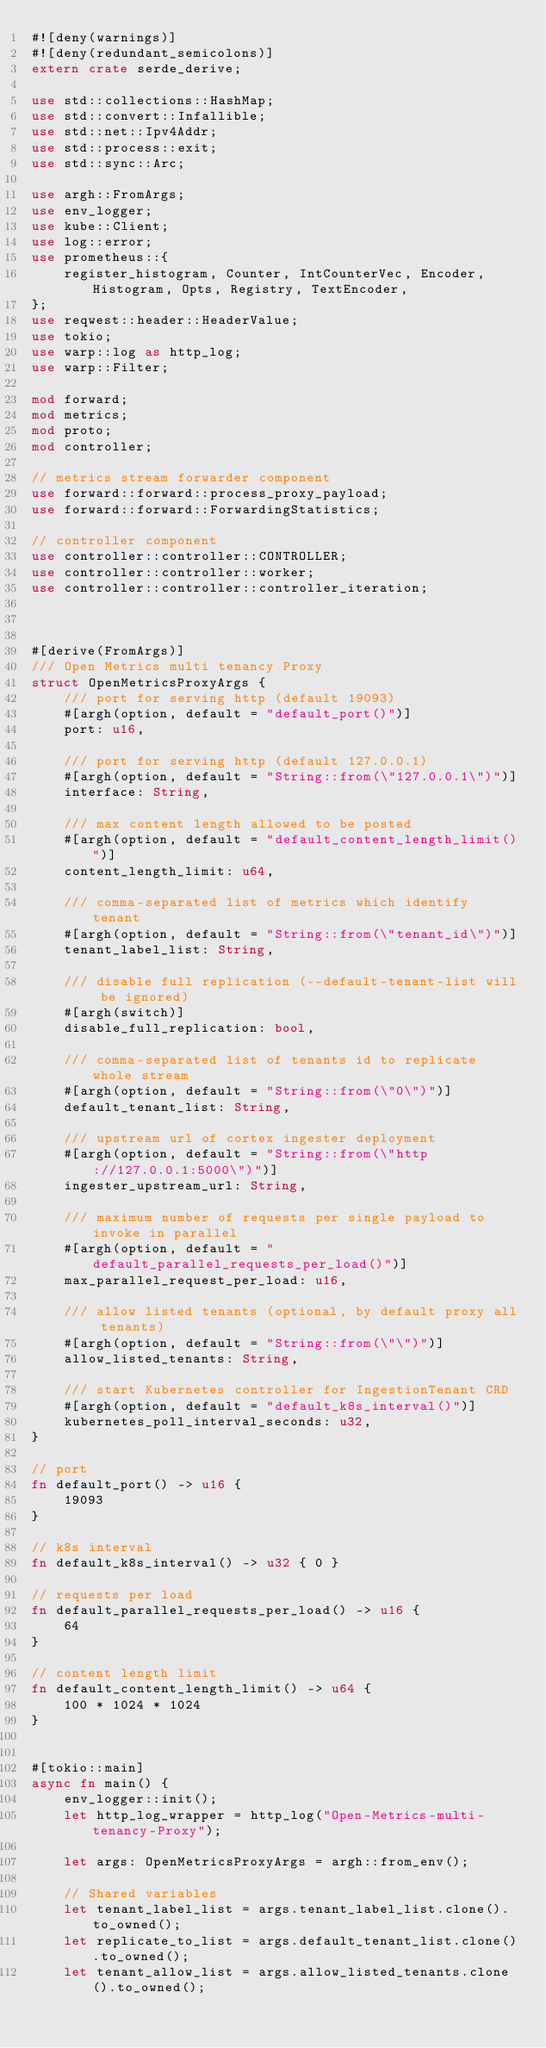<code> <loc_0><loc_0><loc_500><loc_500><_Rust_>#![deny(warnings)]
#![deny(redundant_semicolons)]
extern crate serde_derive;

use std::collections::HashMap;
use std::convert::Infallible;
use std::net::Ipv4Addr;
use std::process::exit;
use std::sync::Arc;

use argh::FromArgs;
use env_logger;
use kube::Client;
use log::error;
use prometheus::{
    register_histogram, Counter, IntCounterVec, Encoder, Histogram, Opts, Registry, TextEncoder,
};
use reqwest::header::HeaderValue;
use tokio;
use warp::log as http_log;
use warp::Filter;

mod forward;
mod metrics;
mod proto;
mod controller;

// metrics stream forwarder component
use forward::forward::process_proxy_payload;
use forward::forward::ForwardingStatistics;

// controller component
use controller::controller::CONTROLLER;
use controller::controller::worker;
use controller::controller::controller_iteration;



#[derive(FromArgs)]
/// Open Metrics multi tenancy Proxy
struct OpenMetricsProxyArgs {
    /// port for serving http (default 19093)
    #[argh(option, default = "default_port()")]
    port: u16,

    /// port for serving http (default 127.0.0.1)
    #[argh(option, default = "String::from(\"127.0.0.1\")")]
    interface: String,

    /// max content length allowed to be posted
    #[argh(option, default = "default_content_length_limit()")]
    content_length_limit: u64,

    /// comma-separated list of metrics which identify tenant
    #[argh(option, default = "String::from(\"tenant_id\")")]
    tenant_label_list: String,

    /// disable full replication (--default-tenant-list will be ignored)
    #[argh(switch)]
    disable_full_replication: bool,

    /// comma-separated list of tenants id to replicate whole stream
    #[argh(option, default = "String::from(\"0\")")]
    default_tenant_list: String,

    /// upstream url of cortex ingester deployment
    #[argh(option, default = "String::from(\"http://127.0.0.1:5000\")")]
    ingester_upstream_url: String,

    /// maximum number of requests per single payload to invoke in parallel
    #[argh(option, default = "default_parallel_requests_per_load()")]
    max_parallel_request_per_load: u16,

    /// allow listed tenants (optional, by default proxy all tenants)
    #[argh(option, default = "String::from(\"\")")]
    allow_listed_tenants: String,

    /// start Kubernetes controller for IngestionTenant CRD
    #[argh(option, default = "default_k8s_interval()")]
    kubernetes_poll_interval_seconds: u32,
}

// port
fn default_port() -> u16 {
    19093
}

// k8s interval
fn default_k8s_interval() -> u32 { 0 }

// requests per load
fn default_parallel_requests_per_load() -> u16 {
    64
}

// content length limit
fn default_content_length_limit() -> u64 {
    100 * 1024 * 1024
}


#[tokio::main]
async fn main() {
    env_logger::init();
    let http_log_wrapper = http_log("Open-Metrics-multi-tenancy-Proxy");

    let args: OpenMetricsProxyArgs = argh::from_env();

    // Shared variables
    let tenant_label_list = args.tenant_label_list.clone().to_owned();
    let replicate_to_list = args.default_tenant_list.clone().to_owned();
    let tenant_allow_list = args.allow_listed_tenants.clone().to_owned();</code> 